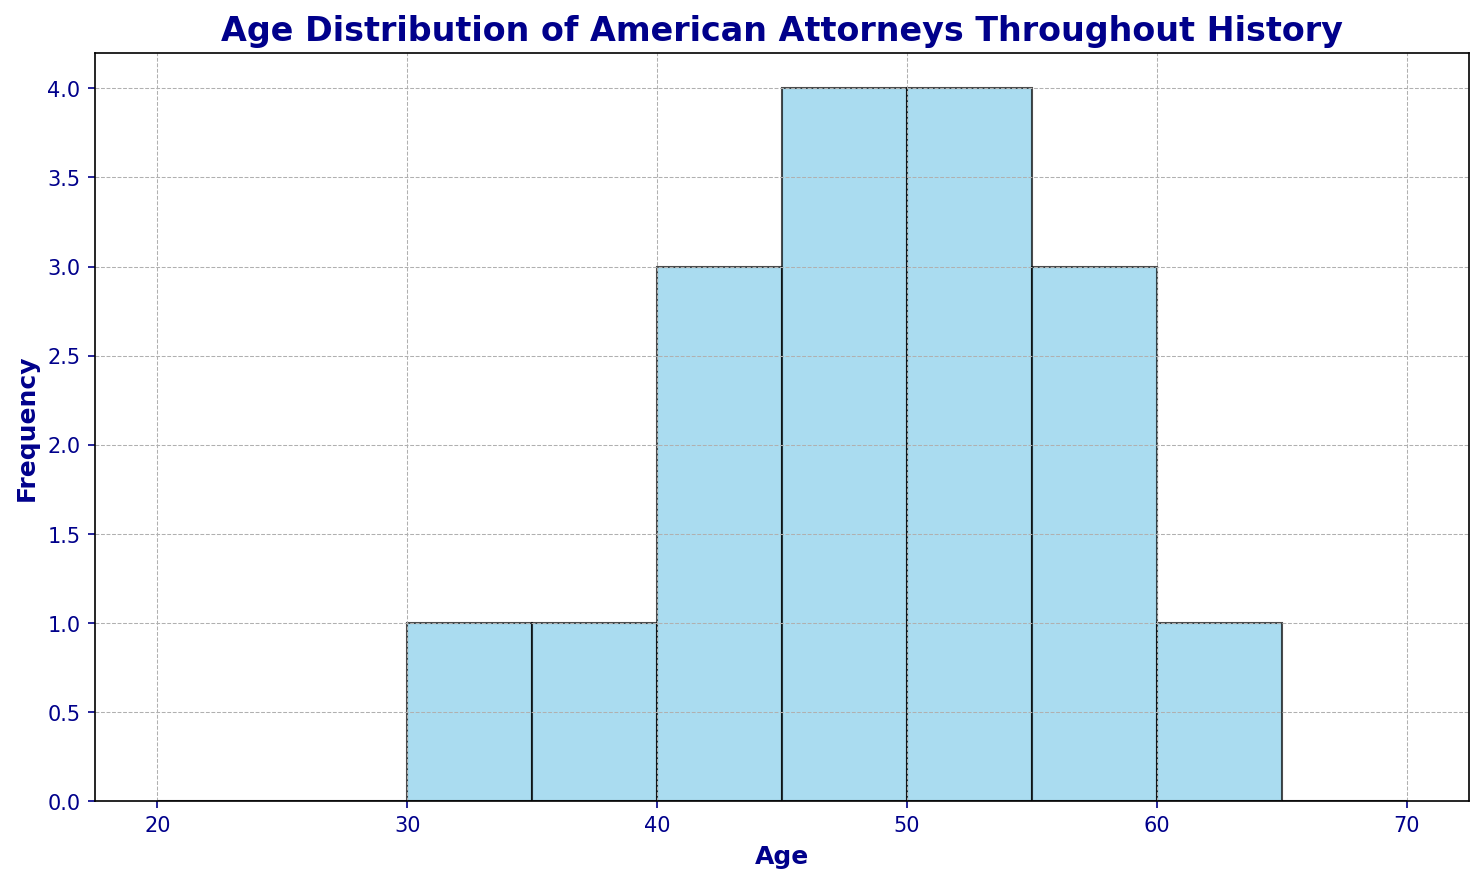What is the age group with the highest frequency of American attorneys? Look at the histogram and identify the tallest bar. The tallest bar corresponds to the age group 55-60. This means the age group with the highest frequency is 55-60.
Answer: 55-60 How many age groups have a frequency of fewer than 3 attorneys? Look at the histogram and count the bars that are shorter than the line representing a frequency of 3. There are bars for the age groups 35-40 and 65-70.
Answer: 2 What is the range of ages for the American attorneys in this data? Identify the minimum and maximum ages by looking at the data distribution in the histogram. The minimum age is 30 and the maximum age is 60. So, the range is 60 - 30.
Answer: 30 Which age group has the lowest frequency of American attorneys? Identify the shortest bar in the histogram, which corresponds to the age group 35-40 with a frequency of 1.
Answer: 35-40 How many age groups have a frequency equal to 5 attorneys? Look at the histogram and count the bars that reach the frequency of 5. The age group for 50-55 reaches the frequency of 5.
Answer: 1 What is the combined frequency of the age groups 50-55 and 55-60? Find the frequencies of these age groups by looking at the heights of the corresponding bars. The frequency of the 50-55 group is 5, and the 55-60 group is 4. Adding them gives 5 + 4 = 9.
Answer: 9 Is the frequency of attorneys aged 60-65 greater than those aged 35-40? Compare the heights of the bars for the age groups 60-65 and 35-40. The 60-65 bar is taller with a frequency of 2 compared to 35-40, which has a frequency of 1.
Answer: Yes What is the average age group frequency? Sum the frequencies of all bars and then divide by the number of bars. The bars have frequencies: 1, 1, 2, 3, 2, 3, 5, 4, 2. The sum is 1+1+2+3+2+3+5+4+2 = 23. There are 9 groups, so the average is 23 / 9.
Answer: 2.56 